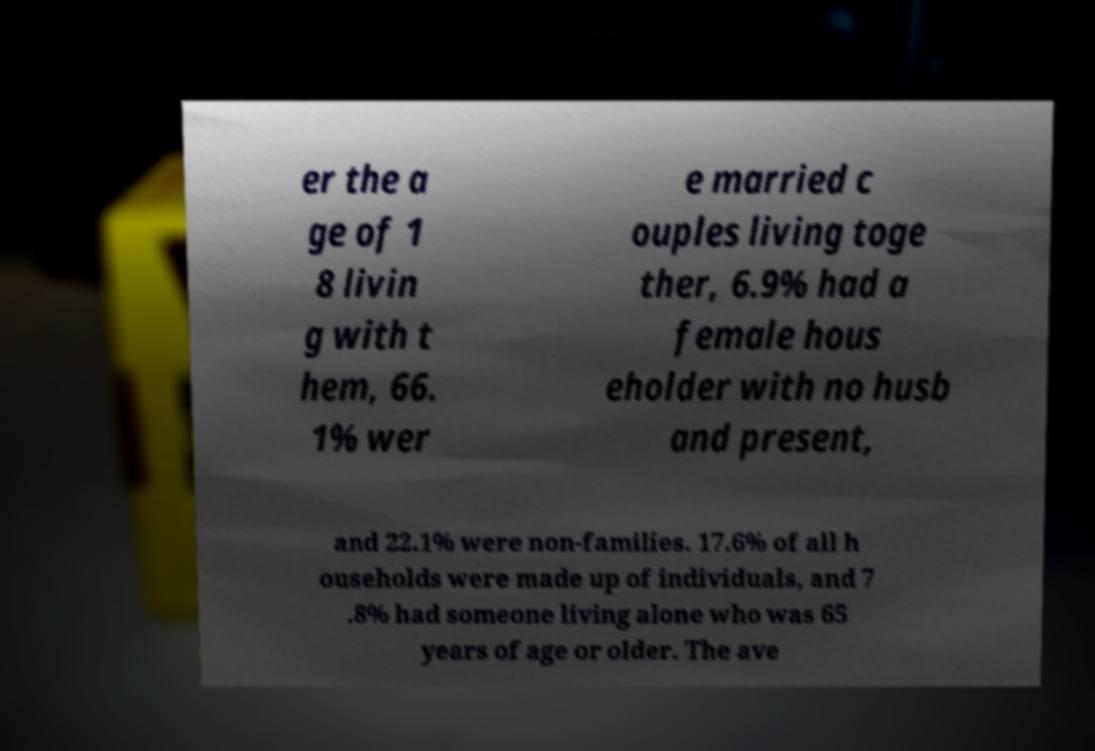I need the written content from this picture converted into text. Can you do that? er the a ge of 1 8 livin g with t hem, 66. 1% wer e married c ouples living toge ther, 6.9% had a female hous eholder with no husb and present, and 22.1% were non-families. 17.6% of all h ouseholds were made up of individuals, and 7 .8% had someone living alone who was 65 years of age or older. The ave 